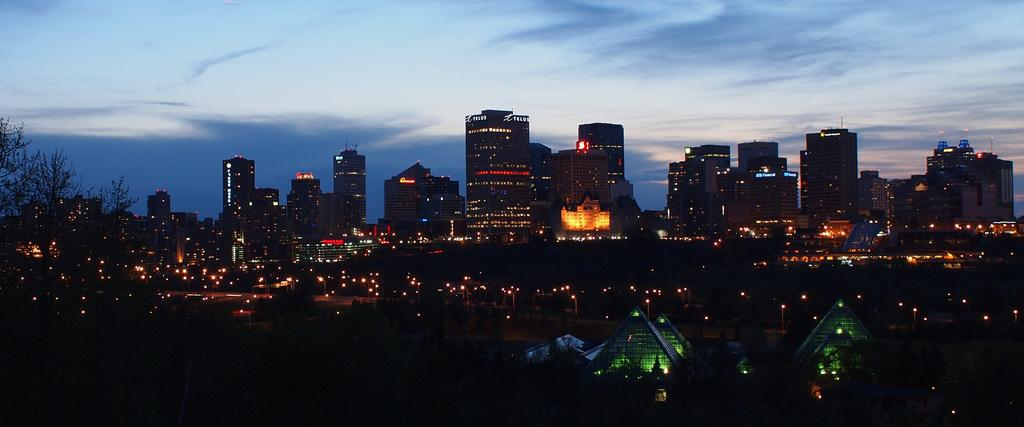What type of structures can be seen in the image? There are buildings in the image. What else is visible in the image besides the buildings? There are lights, trees, and the sky visible in the image. What can be seen in the sky in the image? Clouds are present in the image. How would you describe the overall lighting in the image? The image appears to be slightly dark. How many jellyfish can be seen swimming in the image? There are no jellyfish present in the image; it features buildings, lights, trees, and the sky. What type of flame is visible in the image? There is no flame present in the image. 